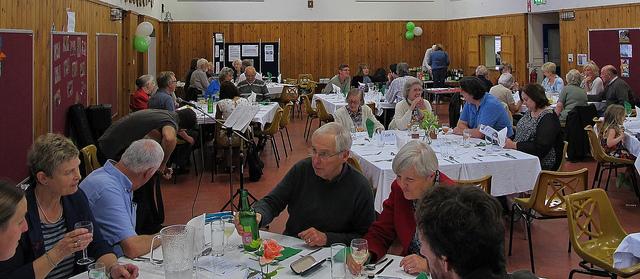What color are the chairs?
Short answer required. Yellow. How many balloons are shown?
Be succinct. 6. Where is the woman holding a wine glass in her right hand?
Answer briefly. Closest table. 